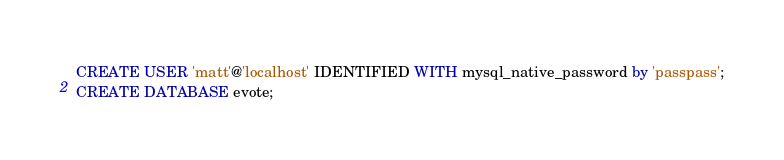Convert code to text. <code><loc_0><loc_0><loc_500><loc_500><_SQL_>CREATE USER 'matt'@'localhost' IDENTIFIED WITH mysql_native_password by 'passpass';
CREATE DATABASE evote;
</code> 